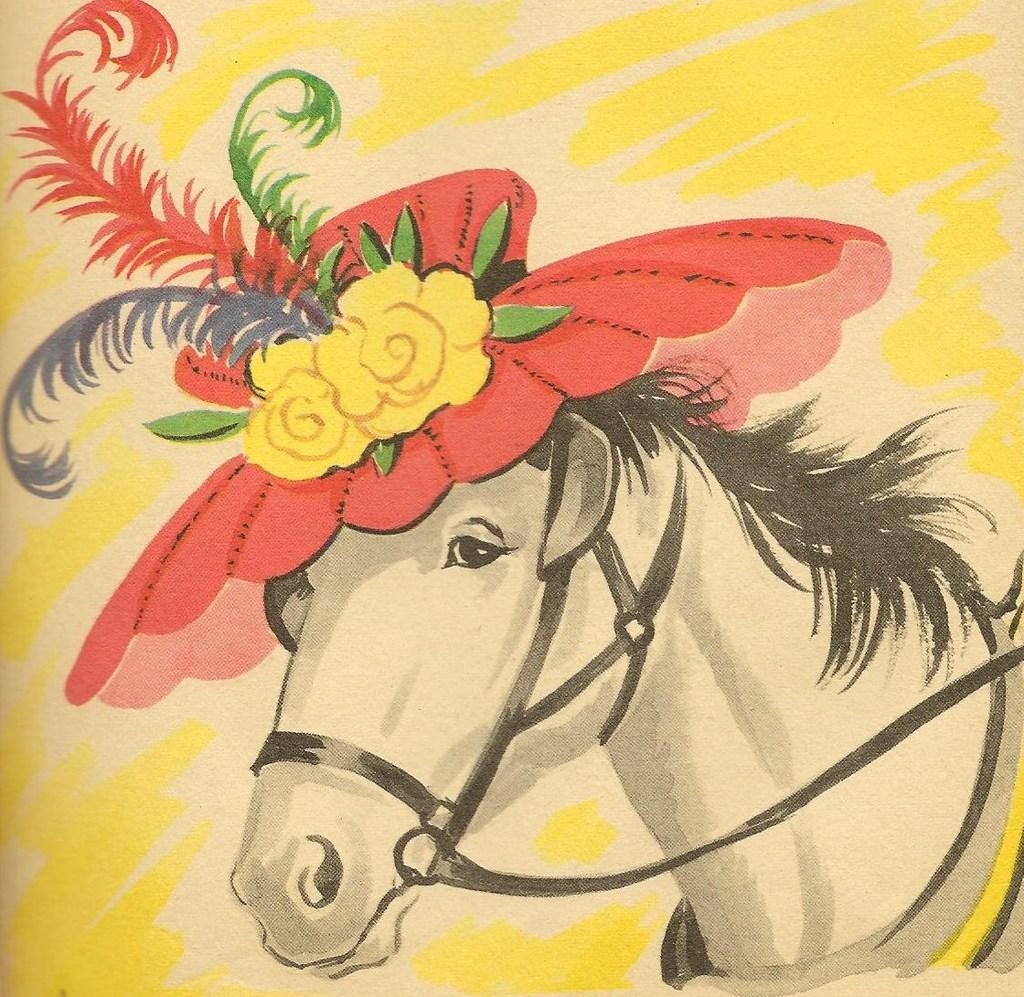What is the main subject of the image? The main subject of the image is a painting. What animals or objects are depicted in the painting? The painting contains a horse. What type of flora is depicted in the painting? The painting contains flowers and leaves. What type of furniture is visible in the painting? There is no furniture present in the painting; it features a horse, flowers, and leaves. What color is the gold basketball in the painting? There is no basketball, gold or otherwise, present in the painting. 